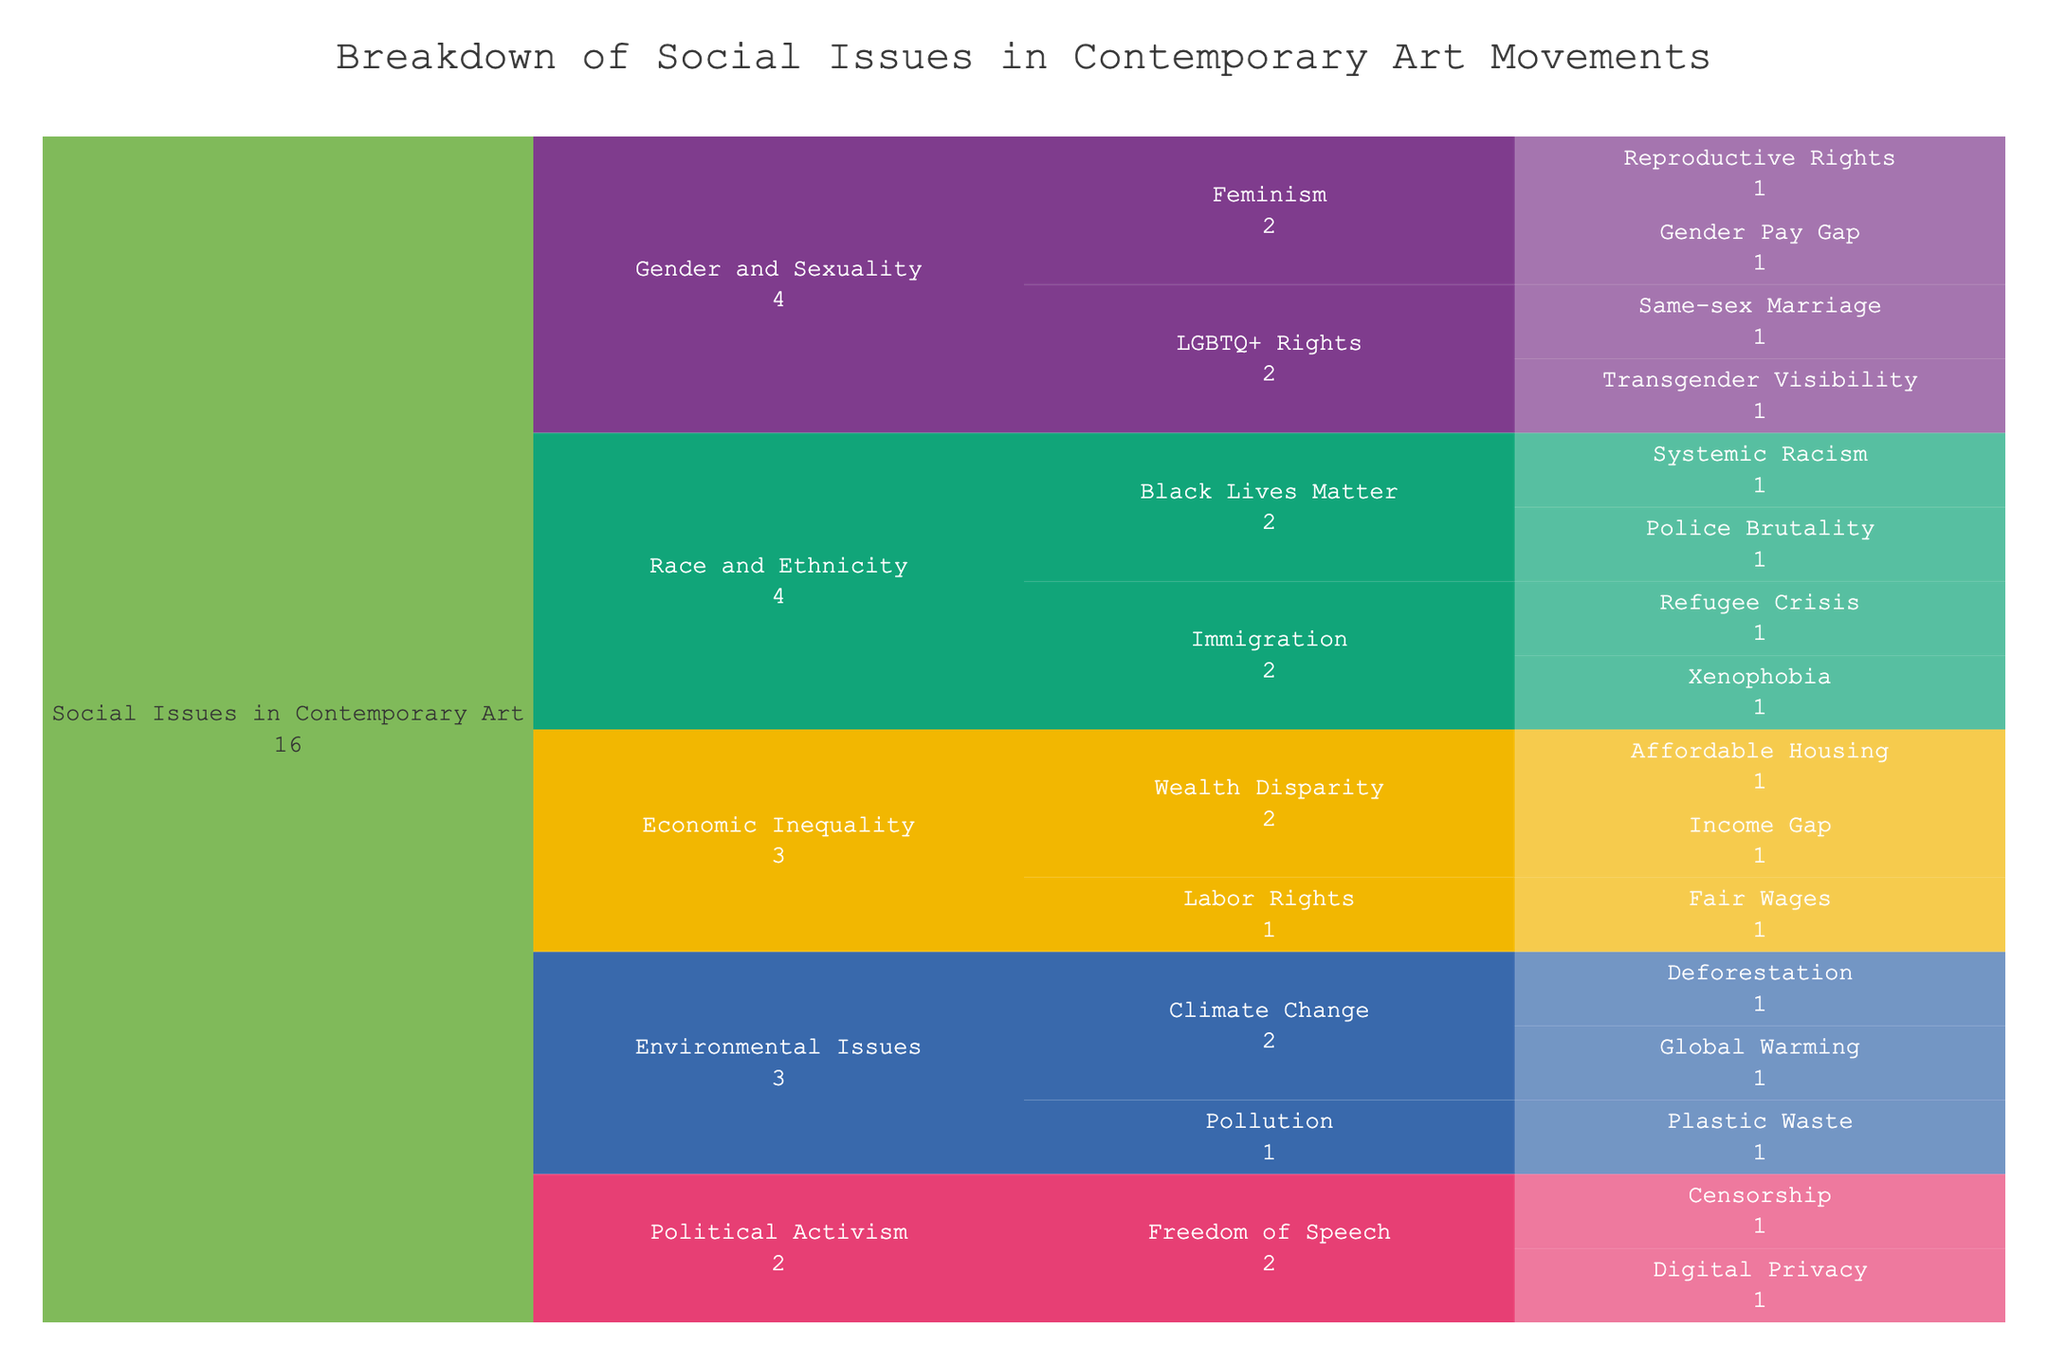What are the main categories of social issues addressed in contemporary art movements? The main categories are on the second level of the icicle chart. Look for them under "Social Issues in Contemporary Art".
Answer: Gender and Sexuality, Race and Ethnicity, Environmental Issues, Economic Inequality, Political Activism How many specific issues are addressed under Gender and Sexuality? Identify the breakdown under "Gender and Sexuality" in the chart. Count all the specific issues listed under both LGBTQ+ Rights and Feminism.
Answer: 4 Which specific issue is common to both Freedom of Speech and Digital Privacy? Explore the subcategories under Political Activism. Since these subcategories cover different issues, note that this is a trick question; Freedom of Speech and Digital Privacy are separate specific issues.
Answer: None What is the shared focus between Police Brutality and Systemic Racism? Both are subcategories of Black Lives Matter under Race and Ethnicity, indicating a focus on racial issues.
Answer: Black Lives Matter Which category has more specific issues: Climate Change or Wealth Disparity? Look under Environmental Issues for Climate Change and Economic Inequality for Wealth Disparity. Count the specific issues listed under each.
Answer: Climate Change How does the number of subcategories under Environmental Issues compare to Race and Ethnicity? Count the subcategories for each of the primary categories, then compare. Environmental Issues have Climate Change and Pollution, Race and Ethnicity has Black Lives Matter and Immigration.
Answer: Equal What are the issues listed under Black Lives Matter? Find Black Lives Matter under Race and Ethnicity in the chart and list the specific issues.
Answer: Police Brutality, Systemic Racism What topics are addressed within Political Activism? Look at the subcategories listed under Political Activism in the chart.
Answer: Freedom of Speech, Digital Privacy Which subcategory under Gender and Sexuality covers more specific issues? Compare the specific issues listed under LGBTQ+ Rights and Feminism.
Answer: LGBTQ+ Rights and Feminism cover equal specific issues (2 each) What is the relationship between the Income Gap and Affordable Housing in the context of social issues? Both are specific issues categorized under Wealth Disparity within Economic Inequality.
Answer: Wealth Disparity 